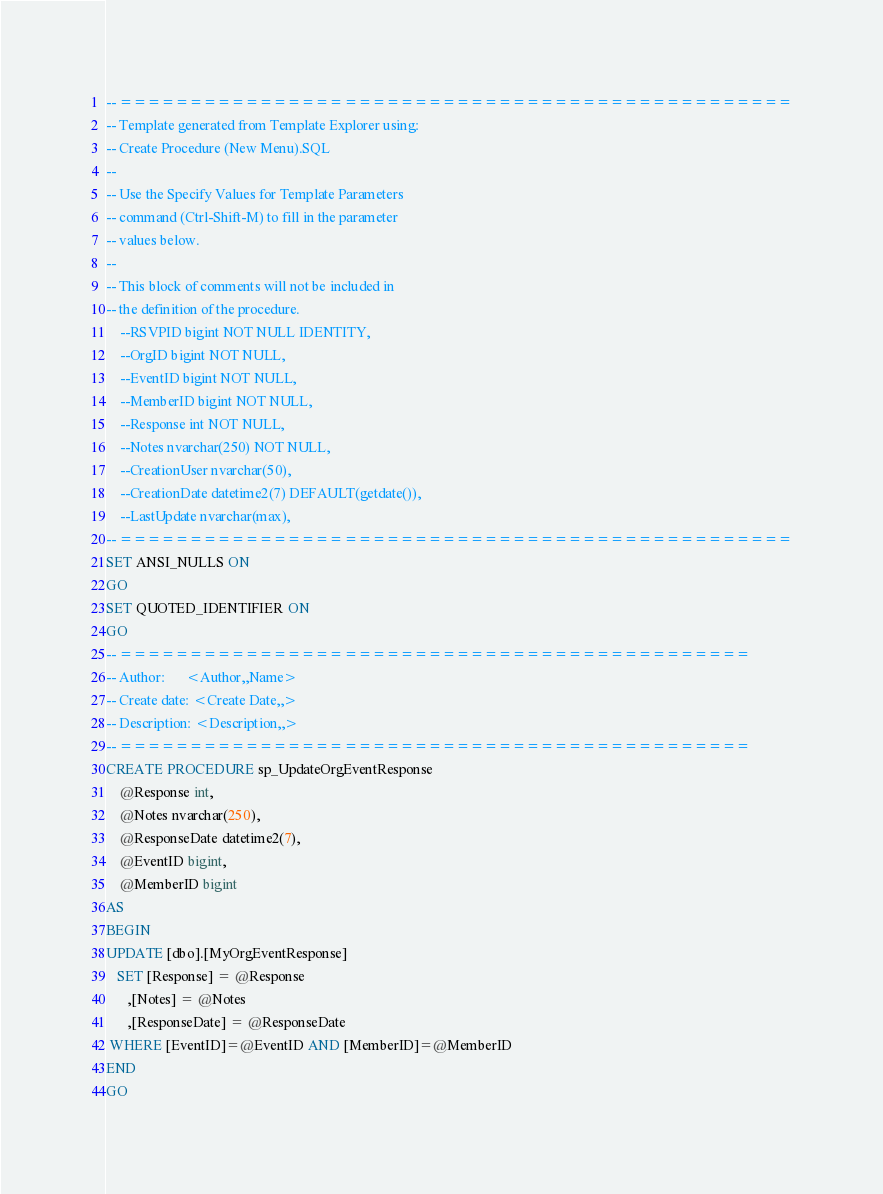Convert code to text. <code><loc_0><loc_0><loc_500><loc_500><_SQL_>-- ================================================
-- Template generated from Template Explorer using:
-- Create Procedure (New Menu).SQL
--
-- Use the Specify Values for Template Parameters 
-- command (Ctrl-Shift-M) to fill in the parameter 
-- values below.
--
-- This block of comments will not be included in
-- the definition of the procedure.
	--RSVPID bigint NOT NULL IDENTITY,
	--OrgID bigint NOT NULL,
	--EventID bigint NOT NULL,
	--MemberID bigint NOT NULL,
	--Response int NOT NULL,
	--Notes nvarchar(250) NOT NULL,
	--CreationUser nvarchar(50),
	--CreationDate datetime2(7) DEFAULT(getdate()),
	--LastUpdate nvarchar(max),
-- ================================================
SET ANSI_NULLS ON
GO
SET QUOTED_IDENTIFIER ON
GO
-- =============================================
-- Author:		<Author,,Name>
-- Create date: <Create Date,,>
-- Description:	<Description,,>
-- =============================================
CREATE PROCEDURE sp_UpdateOrgEventResponse
	@Response int,
	@Notes nvarchar(250),
	@ResponseDate datetime2(7),
	@EventID bigint,
	@MemberID bigint
AS
BEGIN
UPDATE [dbo].[MyOrgEventResponse]
   SET [Response] = @Response
      ,[Notes] = @Notes
	  ,[ResponseDate] = @ResponseDate
 WHERE [EventID]=@EventID AND [MemberID]=@MemberID
END
GO
</code> 